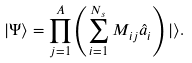<formula> <loc_0><loc_0><loc_500><loc_500>| \Psi \rangle = \prod _ { j = 1 } ^ { A } \left ( \sum _ { i = 1 } ^ { N _ { s } } M _ { i j } \hat { a } _ { i } \right ) | \rangle .</formula> 